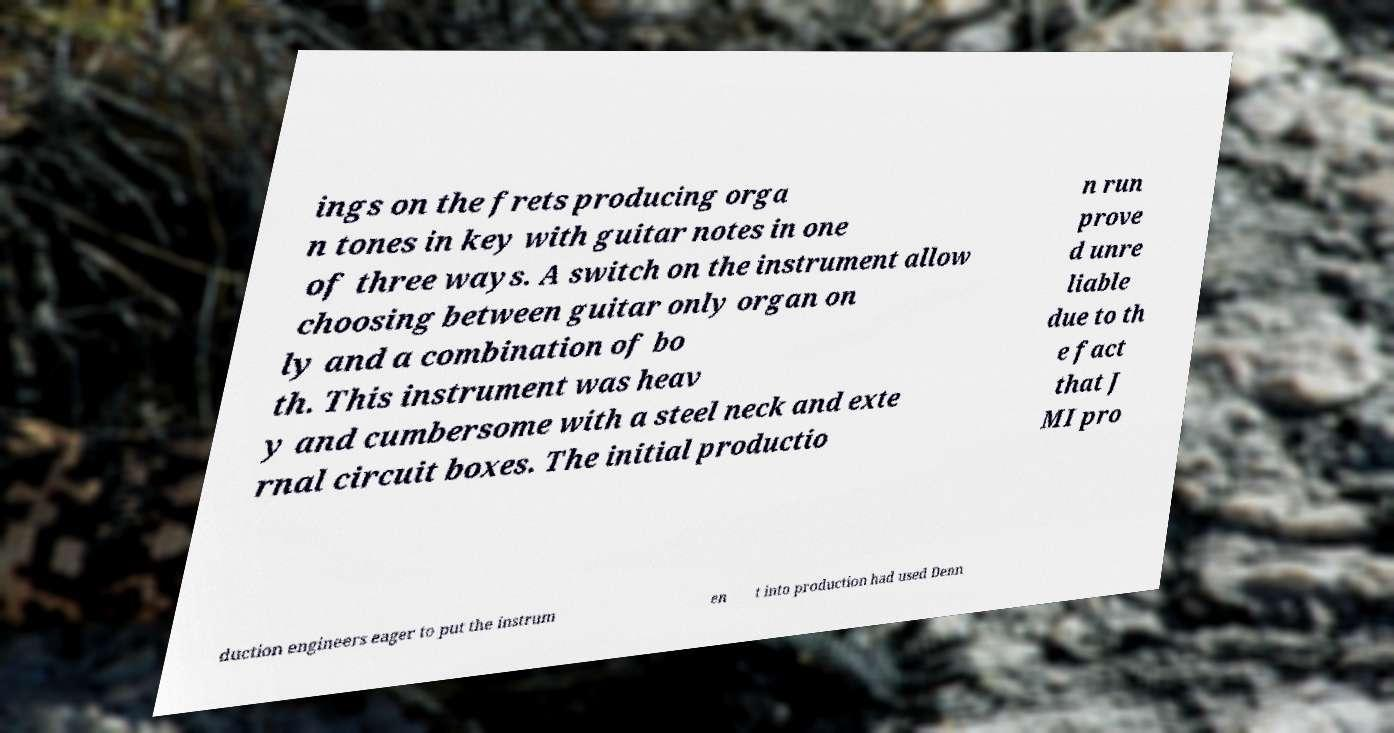Could you extract and type out the text from this image? ings on the frets producing orga n tones in key with guitar notes in one of three ways. A switch on the instrument allow choosing between guitar only organ on ly and a combination of bo th. This instrument was heav y and cumbersome with a steel neck and exte rnal circuit boxes. The initial productio n run prove d unre liable due to th e fact that J MI pro duction engineers eager to put the instrum en t into production had used Denn 